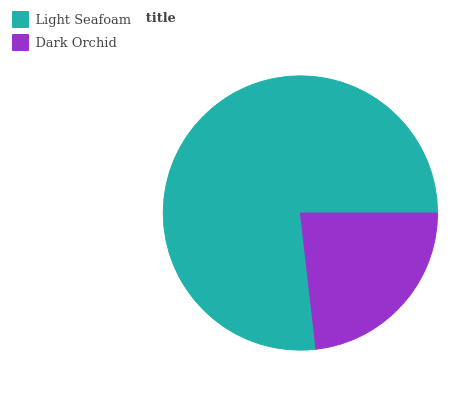Is Dark Orchid the minimum?
Answer yes or no. Yes. Is Light Seafoam the maximum?
Answer yes or no. Yes. Is Dark Orchid the maximum?
Answer yes or no. No. Is Light Seafoam greater than Dark Orchid?
Answer yes or no. Yes. Is Dark Orchid less than Light Seafoam?
Answer yes or no. Yes. Is Dark Orchid greater than Light Seafoam?
Answer yes or no. No. Is Light Seafoam less than Dark Orchid?
Answer yes or no. No. Is Light Seafoam the high median?
Answer yes or no. Yes. Is Dark Orchid the low median?
Answer yes or no. Yes. Is Dark Orchid the high median?
Answer yes or no. No. Is Light Seafoam the low median?
Answer yes or no. No. 